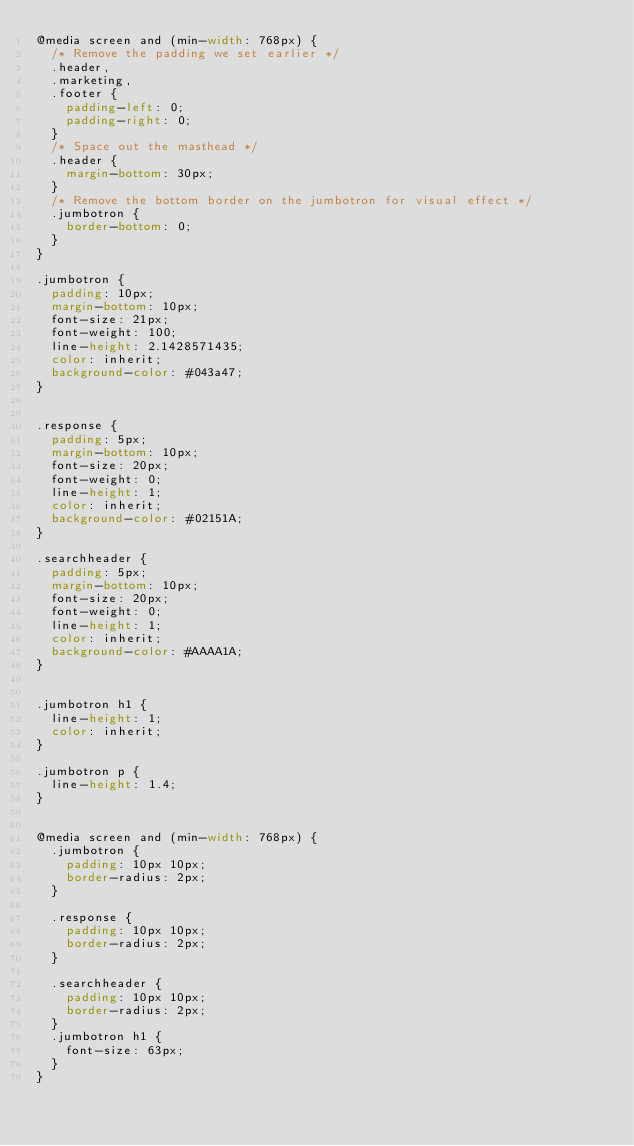<code> <loc_0><loc_0><loc_500><loc_500><_CSS_>@media screen and (min-width: 768px) {
  /* Remove the padding we set earlier */
  .header,
  .marketing,
  .footer {
    padding-left: 0;
    padding-right: 0;
  }
  /* Space out the masthead */
  .header {
    margin-bottom: 30px;
  }
  /* Remove the bottom border on the jumbotron for visual effect */
  .jumbotron {
    border-bottom: 0;
  }
}

.jumbotron {
  padding: 10px;
  margin-bottom: 10px;
  font-size: 21px;
  font-weight: 100;
  line-height: 2.1428571435;
  color: inherit;
  background-color: #043a47;
}


.response {
  padding: 5px;
  margin-bottom: 10px;
  font-size: 20px;
  font-weight: 0;
  line-height: 1;
  color: inherit;
  background-color: #02151A;
}

.searchheader {
  padding: 5px;
  margin-bottom: 10px;
  font-size: 20px;
  font-weight: 0;
  line-height: 1;
  color: inherit;
  background-color: #AAAA1A;
}


.jumbotron h1 {
  line-height: 1;
  color: inherit;
}

.jumbotron p {
  line-height: 1.4;
}


@media screen and (min-width: 768px) {
  .jumbotron {
    padding: 10px 10px;
    border-radius: 2px;
  }
  
  .response {
    padding: 10px 10px;
    border-radius: 2px;
  }
  
  .searchheader {
    padding: 10px 10px;
    border-radius: 2px;
  }
  .jumbotron h1 {
    font-size: 63px;
  }
}</code> 